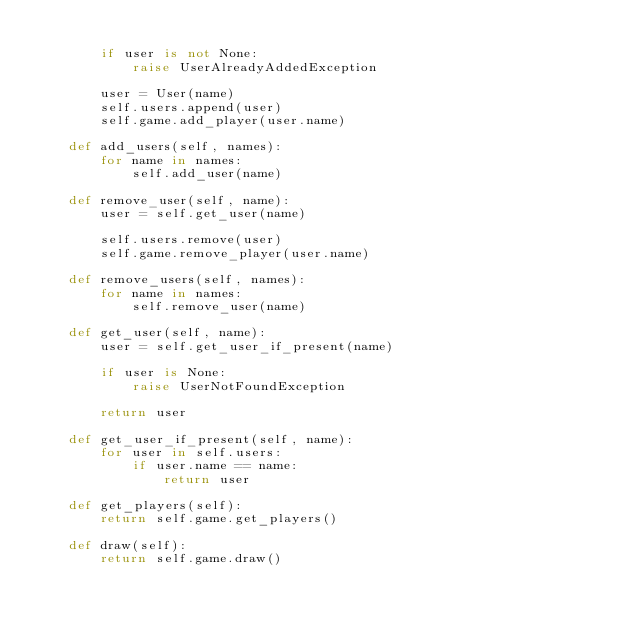Convert code to text. <code><loc_0><loc_0><loc_500><loc_500><_Python_>
        if user is not None:
            raise UserAlreadyAddedException

        user = User(name)
        self.users.append(user)
        self.game.add_player(user.name)

    def add_users(self, names):
        for name in names:
            self.add_user(name)

    def remove_user(self, name):
        user = self.get_user(name)

        self.users.remove(user)
        self.game.remove_player(user.name)

    def remove_users(self, names):
        for name in names:
            self.remove_user(name)

    def get_user(self, name):
        user = self.get_user_if_present(name)

        if user is None:
            raise UserNotFoundException

        return user

    def get_user_if_present(self, name):
        for user in self.users:
            if user.name == name:
                return user

    def get_players(self):
        return self.game.get_players()

    def draw(self):
        return self.game.draw()
</code> 